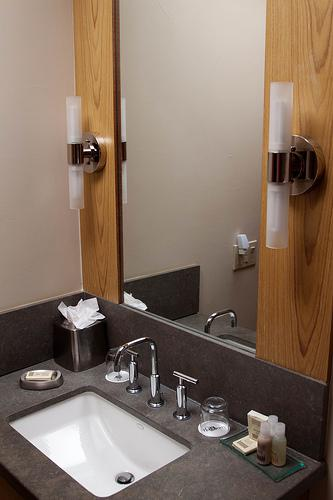Question: where is this scene?
Choices:
A. In the restaurant.
B. In the hotel bathroom.
C. In the bedroom.
D. In the lobby.
Answer with the letter. Answer: B Question: why is there a mirror?
Choices:
A. For grooming.
B. To look at.
C. To change lanes.
D. To reflect light.
Answer with the letter. Answer: A Question: what is in the photo?
Choices:
A. Tub.
B. Toilet.
C. Sink.
D. Shower curtain.
Answer with the letter. Answer: C Question: what color is the mirror?
Choices:
A. Silver.
B. Brown.
C. Grey.
D. White.
Answer with the letter. Answer: B Question: what else is visible?
Choices:
A. Taps.
B. Knobs.
C. Curtains.
D. Faucet.
Answer with the letter. Answer: A 